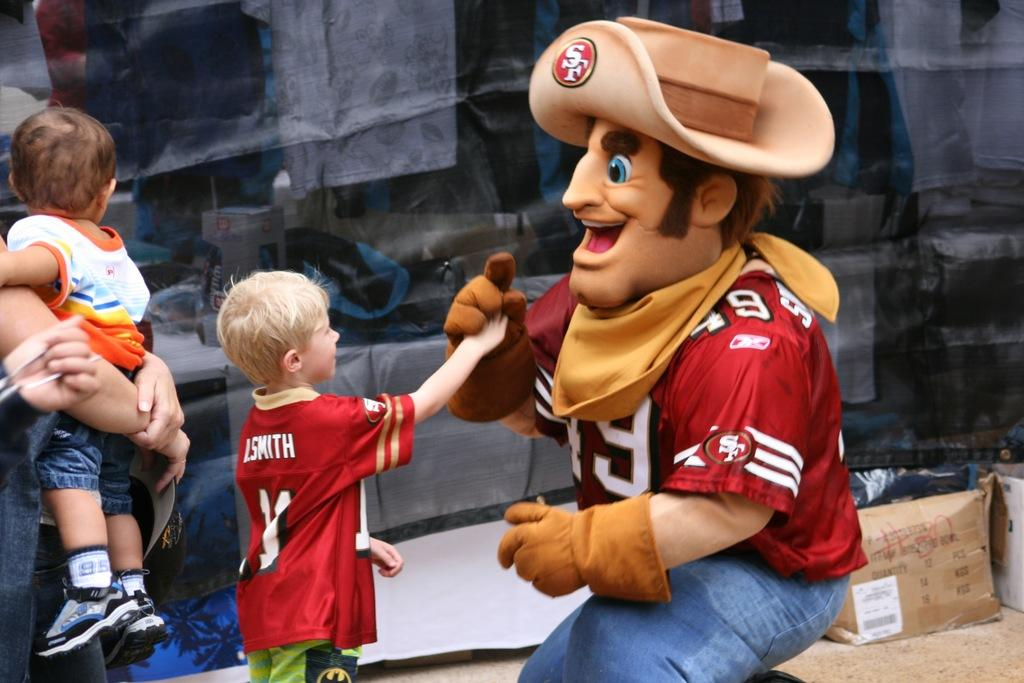<image>
Give a short and clear explanation of the subsequent image. a mascot that has the SF logo on his hat 